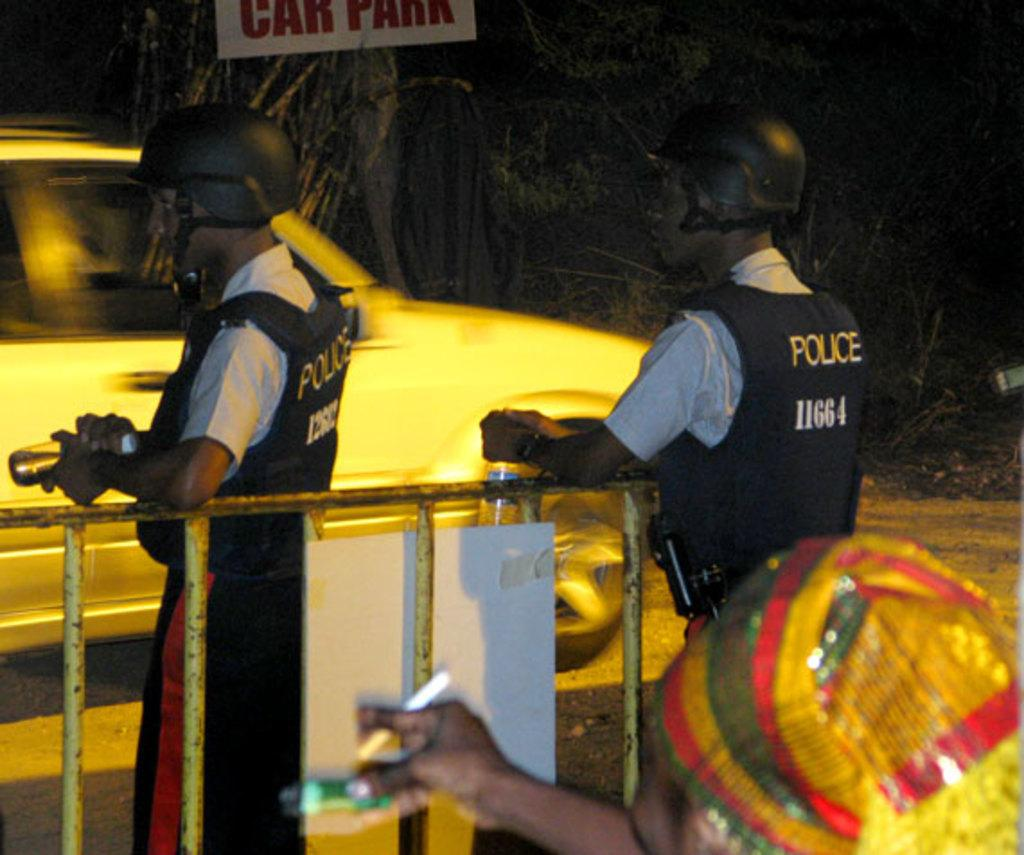Who or what can be seen in the image? There are people in the image. What is the metal fence used for in the image? The metal fence is present in the image, but its purpose is not explicitly stated. What type of vehicle is in the image? There is a car in the image. What is the board used for in the image? The purpose of the board in the image is not explicitly stated. What can be seen in the background of the image? There are trees in the background of the image. Who is the writer of the card in the image? There is no card present in the image, so it is not possible to determine who the writer might be. 